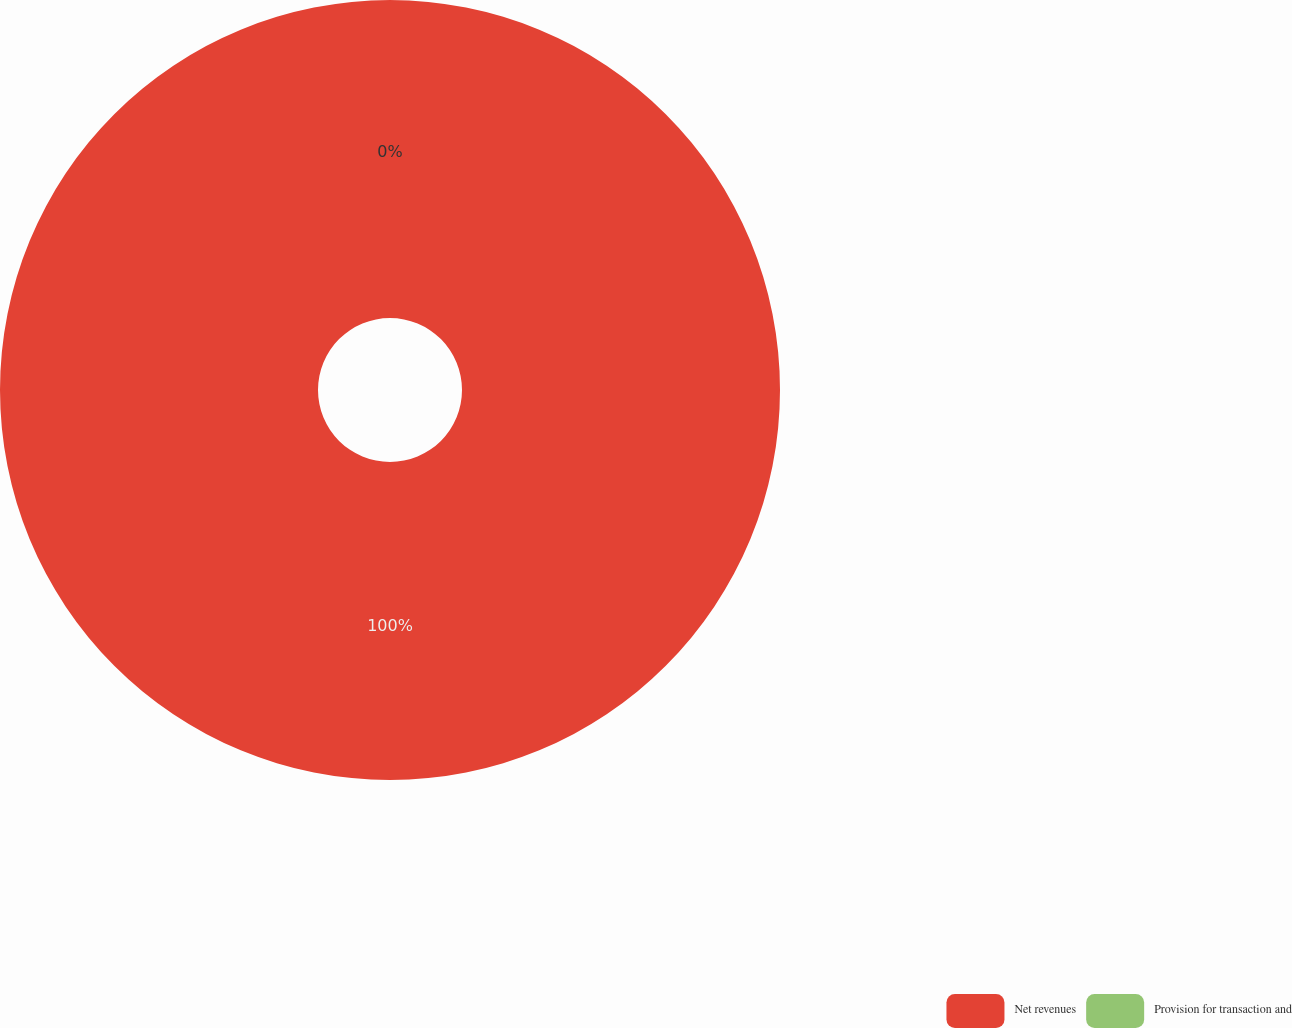Convert chart to OTSL. <chart><loc_0><loc_0><loc_500><loc_500><pie_chart><fcel>Net revenues<fcel>Provision for transaction and<nl><fcel>100.0%<fcel>0.0%<nl></chart> 